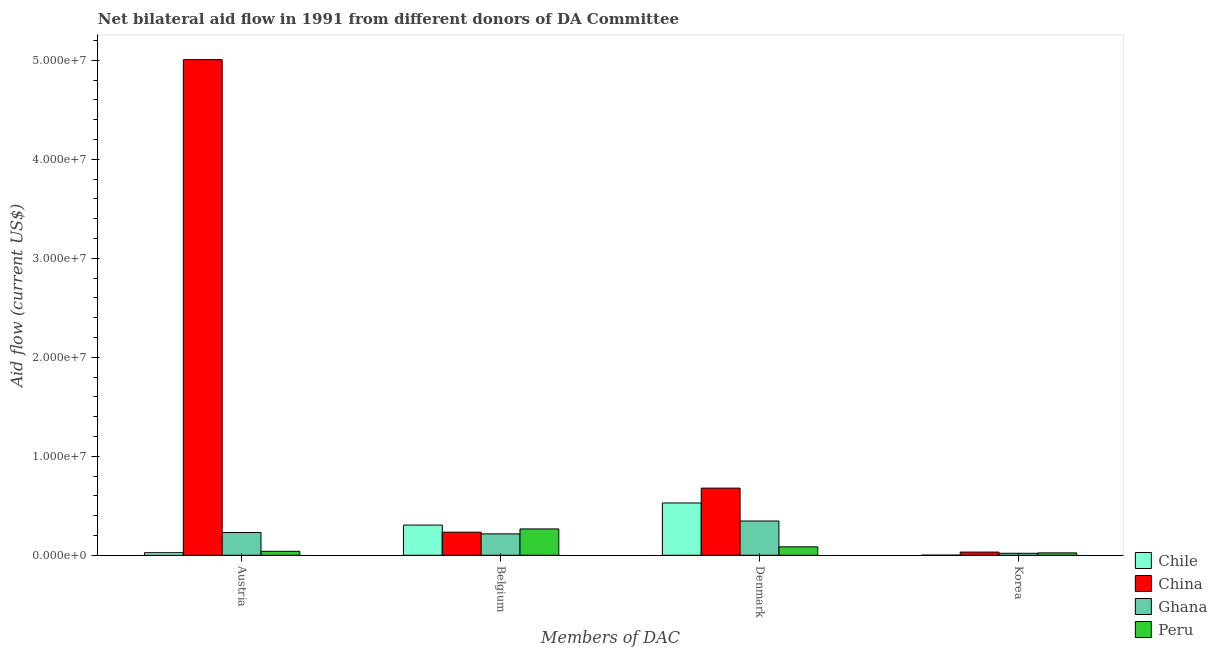How many different coloured bars are there?
Provide a short and direct response. 4. Are the number of bars on each tick of the X-axis equal?
Make the answer very short. Yes. How many bars are there on the 3rd tick from the left?
Give a very brief answer. 4. How many bars are there on the 1st tick from the right?
Your answer should be compact. 4. What is the label of the 4th group of bars from the left?
Provide a succinct answer. Korea. What is the amount of aid given by denmark in China?
Your answer should be compact. 6.78e+06. Across all countries, what is the maximum amount of aid given by korea?
Offer a terse response. 3.20e+05. Across all countries, what is the minimum amount of aid given by denmark?
Your response must be concise. 8.50e+05. In which country was the amount of aid given by belgium maximum?
Provide a short and direct response. Chile. What is the total amount of aid given by korea in the graph?
Offer a terse response. 7.70e+05. What is the difference between the amount of aid given by belgium in Chile and that in Ghana?
Ensure brevity in your answer.  8.90e+05. What is the difference between the amount of aid given by austria in Chile and the amount of aid given by korea in Peru?
Provide a succinct answer. 2.00e+04. What is the average amount of aid given by korea per country?
Offer a very short reply. 1.92e+05. What is the difference between the amount of aid given by korea and amount of aid given by belgium in Peru?
Make the answer very short. -2.42e+06. In how many countries, is the amount of aid given by korea greater than 32000000 US$?
Provide a succinct answer. 0. What is the ratio of the amount of aid given by austria in Chile to that in Ghana?
Your answer should be compact. 0.11. Is the difference between the amount of aid given by korea in Peru and Ghana greater than the difference between the amount of aid given by austria in Peru and Ghana?
Provide a short and direct response. Yes. What is the difference between the highest and the second highest amount of aid given by austria?
Keep it short and to the point. 4.78e+07. What is the difference between the highest and the lowest amount of aid given by austria?
Keep it short and to the point. 4.98e+07. In how many countries, is the amount of aid given by belgium greater than the average amount of aid given by belgium taken over all countries?
Keep it short and to the point. 2. Is it the case that in every country, the sum of the amount of aid given by austria and amount of aid given by denmark is greater than the sum of amount of aid given by belgium and amount of aid given by korea?
Give a very brief answer. No. Is it the case that in every country, the sum of the amount of aid given by austria and amount of aid given by belgium is greater than the amount of aid given by denmark?
Give a very brief answer. No. Are all the bars in the graph horizontal?
Provide a succinct answer. No. Does the graph contain grids?
Provide a short and direct response. No. Where does the legend appear in the graph?
Offer a terse response. Bottom right. How many legend labels are there?
Provide a short and direct response. 4. What is the title of the graph?
Provide a succinct answer. Net bilateral aid flow in 1991 from different donors of DA Committee. What is the label or title of the X-axis?
Your answer should be compact. Members of DAC. What is the label or title of the Y-axis?
Provide a short and direct response. Aid flow (current US$). What is the Aid flow (current US$) of Chile in Austria?
Ensure brevity in your answer.  2.60e+05. What is the Aid flow (current US$) of China in Austria?
Your answer should be very brief. 5.01e+07. What is the Aid flow (current US$) in Ghana in Austria?
Ensure brevity in your answer.  2.30e+06. What is the Aid flow (current US$) of Peru in Austria?
Your response must be concise. 4.00e+05. What is the Aid flow (current US$) in Chile in Belgium?
Make the answer very short. 3.05e+06. What is the Aid flow (current US$) of China in Belgium?
Ensure brevity in your answer.  2.33e+06. What is the Aid flow (current US$) of Ghana in Belgium?
Your answer should be very brief. 2.16e+06. What is the Aid flow (current US$) in Peru in Belgium?
Provide a succinct answer. 2.66e+06. What is the Aid flow (current US$) of Chile in Denmark?
Provide a succinct answer. 5.28e+06. What is the Aid flow (current US$) of China in Denmark?
Keep it short and to the point. 6.78e+06. What is the Aid flow (current US$) in Ghana in Denmark?
Provide a succinct answer. 3.46e+06. What is the Aid flow (current US$) of Peru in Denmark?
Provide a succinct answer. 8.50e+05. What is the Aid flow (current US$) of Chile in Korea?
Provide a short and direct response. 10000. What is the Aid flow (current US$) in Ghana in Korea?
Your response must be concise. 2.00e+05. Across all Members of DAC, what is the maximum Aid flow (current US$) of Chile?
Your answer should be very brief. 5.28e+06. Across all Members of DAC, what is the maximum Aid flow (current US$) in China?
Give a very brief answer. 5.01e+07. Across all Members of DAC, what is the maximum Aid flow (current US$) in Ghana?
Your response must be concise. 3.46e+06. Across all Members of DAC, what is the maximum Aid flow (current US$) in Peru?
Provide a succinct answer. 2.66e+06. Across all Members of DAC, what is the minimum Aid flow (current US$) of Ghana?
Keep it short and to the point. 2.00e+05. What is the total Aid flow (current US$) of Chile in the graph?
Your response must be concise. 8.60e+06. What is the total Aid flow (current US$) of China in the graph?
Offer a terse response. 5.95e+07. What is the total Aid flow (current US$) of Ghana in the graph?
Give a very brief answer. 8.12e+06. What is the total Aid flow (current US$) of Peru in the graph?
Your answer should be very brief. 4.15e+06. What is the difference between the Aid flow (current US$) in Chile in Austria and that in Belgium?
Your answer should be compact. -2.79e+06. What is the difference between the Aid flow (current US$) in China in Austria and that in Belgium?
Your response must be concise. 4.77e+07. What is the difference between the Aid flow (current US$) of Peru in Austria and that in Belgium?
Give a very brief answer. -2.26e+06. What is the difference between the Aid flow (current US$) of Chile in Austria and that in Denmark?
Offer a very short reply. -5.02e+06. What is the difference between the Aid flow (current US$) in China in Austria and that in Denmark?
Ensure brevity in your answer.  4.33e+07. What is the difference between the Aid flow (current US$) in Ghana in Austria and that in Denmark?
Give a very brief answer. -1.16e+06. What is the difference between the Aid flow (current US$) in Peru in Austria and that in Denmark?
Make the answer very short. -4.50e+05. What is the difference between the Aid flow (current US$) in China in Austria and that in Korea?
Make the answer very short. 4.97e+07. What is the difference between the Aid flow (current US$) of Ghana in Austria and that in Korea?
Give a very brief answer. 2.10e+06. What is the difference between the Aid flow (current US$) of Peru in Austria and that in Korea?
Your answer should be very brief. 1.60e+05. What is the difference between the Aid flow (current US$) in Chile in Belgium and that in Denmark?
Ensure brevity in your answer.  -2.23e+06. What is the difference between the Aid flow (current US$) in China in Belgium and that in Denmark?
Provide a short and direct response. -4.45e+06. What is the difference between the Aid flow (current US$) in Ghana in Belgium and that in Denmark?
Provide a short and direct response. -1.30e+06. What is the difference between the Aid flow (current US$) of Peru in Belgium and that in Denmark?
Your answer should be very brief. 1.81e+06. What is the difference between the Aid flow (current US$) in Chile in Belgium and that in Korea?
Your answer should be very brief. 3.04e+06. What is the difference between the Aid flow (current US$) of China in Belgium and that in Korea?
Provide a short and direct response. 2.01e+06. What is the difference between the Aid flow (current US$) in Ghana in Belgium and that in Korea?
Your response must be concise. 1.96e+06. What is the difference between the Aid flow (current US$) of Peru in Belgium and that in Korea?
Provide a succinct answer. 2.42e+06. What is the difference between the Aid flow (current US$) of Chile in Denmark and that in Korea?
Offer a terse response. 5.27e+06. What is the difference between the Aid flow (current US$) of China in Denmark and that in Korea?
Offer a terse response. 6.46e+06. What is the difference between the Aid flow (current US$) in Ghana in Denmark and that in Korea?
Offer a very short reply. 3.26e+06. What is the difference between the Aid flow (current US$) of Chile in Austria and the Aid flow (current US$) of China in Belgium?
Keep it short and to the point. -2.07e+06. What is the difference between the Aid flow (current US$) in Chile in Austria and the Aid flow (current US$) in Ghana in Belgium?
Provide a short and direct response. -1.90e+06. What is the difference between the Aid flow (current US$) in Chile in Austria and the Aid flow (current US$) in Peru in Belgium?
Your response must be concise. -2.40e+06. What is the difference between the Aid flow (current US$) of China in Austria and the Aid flow (current US$) of Ghana in Belgium?
Your response must be concise. 4.79e+07. What is the difference between the Aid flow (current US$) in China in Austria and the Aid flow (current US$) in Peru in Belgium?
Your response must be concise. 4.74e+07. What is the difference between the Aid flow (current US$) in Ghana in Austria and the Aid flow (current US$) in Peru in Belgium?
Provide a short and direct response. -3.60e+05. What is the difference between the Aid flow (current US$) in Chile in Austria and the Aid flow (current US$) in China in Denmark?
Keep it short and to the point. -6.52e+06. What is the difference between the Aid flow (current US$) of Chile in Austria and the Aid flow (current US$) of Ghana in Denmark?
Your response must be concise. -3.20e+06. What is the difference between the Aid flow (current US$) in Chile in Austria and the Aid flow (current US$) in Peru in Denmark?
Provide a succinct answer. -5.90e+05. What is the difference between the Aid flow (current US$) in China in Austria and the Aid flow (current US$) in Ghana in Denmark?
Your response must be concise. 4.66e+07. What is the difference between the Aid flow (current US$) in China in Austria and the Aid flow (current US$) in Peru in Denmark?
Offer a terse response. 4.92e+07. What is the difference between the Aid flow (current US$) in Ghana in Austria and the Aid flow (current US$) in Peru in Denmark?
Provide a short and direct response. 1.45e+06. What is the difference between the Aid flow (current US$) of Chile in Austria and the Aid flow (current US$) of Peru in Korea?
Your response must be concise. 2.00e+04. What is the difference between the Aid flow (current US$) of China in Austria and the Aid flow (current US$) of Ghana in Korea?
Provide a short and direct response. 4.99e+07. What is the difference between the Aid flow (current US$) of China in Austria and the Aid flow (current US$) of Peru in Korea?
Offer a terse response. 4.98e+07. What is the difference between the Aid flow (current US$) in Ghana in Austria and the Aid flow (current US$) in Peru in Korea?
Give a very brief answer. 2.06e+06. What is the difference between the Aid flow (current US$) in Chile in Belgium and the Aid flow (current US$) in China in Denmark?
Offer a very short reply. -3.73e+06. What is the difference between the Aid flow (current US$) in Chile in Belgium and the Aid flow (current US$) in Ghana in Denmark?
Your response must be concise. -4.10e+05. What is the difference between the Aid flow (current US$) in Chile in Belgium and the Aid flow (current US$) in Peru in Denmark?
Provide a short and direct response. 2.20e+06. What is the difference between the Aid flow (current US$) in China in Belgium and the Aid flow (current US$) in Ghana in Denmark?
Your answer should be compact. -1.13e+06. What is the difference between the Aid flow (current US$) in China in Belgium and the Aid flow (current US$) in Peru in Denmark?
Provide a succinct answer. 1.48e+06. What is the difference between the Aid flow (current US$) in Ghana in Belgium and the Aid flow (current US$) in Peru in Denmark?
Your answer should be very brief. 1.31e+06. What is the difference between the Aid flow (current US$) of Chile in Belgium and the Aid flow (current US$) of China in Korea?
Provide a short and direct response. 2.73e+06. What is the difference between the Aid flow (current US$) in Chile in Belgium and the Aid flow (current US$) in Ghana in Korea?
Give a very brief answer. 2.85e+06. What is the difference between the Aid flow (current US$) of Chile in Belgium and the Aid flow (current US$) of Peru in Korea?
Your response must be concise. 2.81e+06. What is the difference between the Aid flow (current US$) of China in Belgium and the Aid flow (current US$) of Ghana in Korea?
Your answer should be compact. 2.13e+06. What is the difference between the Aid flow (current US$) in China in Belgium and the Aid flow (current US$) in Peru in Korea?
Keep it short and to the point. 2.09e+06. What is the difference between the Aid flow (current US$) of Ghana in Belgium and the Aid flow (current US$) of Peru in Korea?
Offer a terse response. 1.92e+06. What is the difference between the Aid flow (current US$) in Chile in Denmark and the Aid flow (current US$) in China in Korea?
Give a very brief answer. 4.96e+06. What is the difference between the Aid flow (current US$) of Chile in Denmark and the Aid flow (current US$) of Ghana in Korea?
Make the answer very short. 5.08e+06. What is the difference between the Aid flow (current US$) in Chile in Denmark and the Aid flow (current US$) in Peru in Korea?
Give a very brief answer. 5.04e+06. What is the difference between the Aid flow (current US$) of China in Denmark and the Aid flow (current US$) of Ghana in Korea?
Provide a short and direct response. 6.58e+06. What is the difference between the Aid flow (current US$) in China in Denmark and the Aid flow (current US$) in Peru in Korea?
Your response must be concise. 6.54e+06. What is the difference between the Aid flow (current US$) in Ghana in Denmark and the Aid flow (current US$) in Peru in Korea?
Provide a succinct answer. 3.22e+06. What is the average Aid flow (current US$) in Chile per Members of DAC?
Your answer should be compact. 2.15e+06. What is the average Aid flow (current US$) of China per Members of DAC?
Offer a very short reply. 1.49e+07. What is the average Aid flow (current US$) of Ghana per Members of DAC?
Keep it short and to the point. 2.03e+06. What is the average Aid flow (current US$) of Peru per Members of DAC?
Give a very brief answer. 1.04e+06. What is the difference between the Aid flow (current US$) in Chile and Aid flow (current US$) in China in Austria?
Offer a very short reply. -4.98e+07. What is the difference between the Aid flow (current US$) of Chile and Aid flow (current US$) of Ghana in Austria?
Provide a succinct answer. -2.04e+06. What is the difference between the Aid flow (current US$) of China and Aid flow (current US$) of Ghana in Austria?
Make the answer very short. 4.78e+07. What is the difference between the Aid flow (current US$) in China and Aid flow (current US$) in Peru in Austria?
Offer a terse response. 4.97e+07. What is the difference between the Aid flow (current US$) in Ghana and Aid flow (current US$) in Peru in Austria?
Provide a succinct answer. 1.90e+06. What is the difference between the Aid flow (current US$) of Chile and Aid flow (current US$) of China in Belgium?
Your answer should be compact. 7.20e+05. What is the difference between the Aid flow (current US$) in Chile and Aid flow (current US$) in Ghana in Belgium?
Provide a succinct answer. 8.90e+05. What is the difference between the Aid flow (current US$) in Chile and Aid flow (current US$) in Peru in Belgium?
Your response must be concise. 3.90e+05. What is the difference between the Aid flow (current US$) in China and Aid flow (current US$) in Ghana in Belgium?
Give a very brief answer. 1.70e+05. What is the difference between the Aid flow (current US$) of China and Aid flow (current US$) of Peru in Belgium?
Your answer should be very brief. -3.30e+05. What is the difference between the Aid flow (current US$) in Ghana and Aid flow (current US$) in Peru in Belgium?
Your response must be concise. -5.00e+05. What is the difference between the Aid flow (current US$) of Chile and Aid flow (current US$) of China in Denmark?
Your answer should be very brief. -1.50e+06. What is the difference between the Aid flow (current US$) of Chile and Aid flow (current US$) of Ghana in Denmark?
Your response must be concise. 1.82e+06. What is the difference between the Aid flow (current US$) in Chile and Aid flow (current US$) in Peru in Denmark?
Give a very brief answer. 4.43e+06. What is the difference between the Aid flow (current US$) of China and Aid flow (current US$) of Ghana in Denmark?
Give a very brief answer. 3.32e+06. What is the difference between the Aid flow (current US$) in China and Aid flow (current US$) in Peru in Denmark?
Provide a succinct answer. 5.93e+06. What is the difference between the Aid flow (current US$) of Ghana and Aid flow (current US$) of Peru in Denmark?
Provide a short and direct response. 2.61e+06. What is the difference between the Aid flow (current US$) of Chile and Aid flow (current US$) of China in Korea?
Provide a succinct answer. -3.10e+05. What is the difference between the Aid flow (current US$) of Chile and Aid flow (current US$) of Ghana in Korea?
Your response must be concise. -1.90e+05. What is the difference between the Aid flow (current US$) of China and Aid flow (current US$) of Ghana in Korea?
Make the answer very short. 1.20e+05. What is the difference between the Aid flow (current US$) in Ghana and Aid flow (current US$) in Peru in Korea?
Keep it short and to the point. -4.00e+04. What is the ratio of the Aid flow (current US$) in Chile in Austria to that in Belgium?
Keep it short and to the point. 0.09. What is the ratio of the Aid flow (current US$) in China in Austria to that in Belgium?
Provide a short and direct response. 21.48. What is the ratio of the Aid flow (current US$) in Ghana in Austria to that in Belgium?
Offer a very short reply. 1.06. What is the ratio of the Aid flow (current US$) of Peru in Austria to that in Belgium?
Your answer should be compact. 0.15. What is the ratio of the Aid flow (current US$) in Chile in Austria to that in Denmark?
Offer a terse response. 0.05. What is the ratio of the Aid flow (current US$) in China in Austria to that in Denmark?
Ensure brevity in your answer.  7.38. What is the ratio of the Aid flow (current US$) in Ghana in Austria to that in Denmark?
Ensure brevity in your answer.  0.66. What is the ratio of the Aid flow (current US$) of Peru in Austria to that in Denmark?
Make the answer very short. 0.47. What is the ratio of the Aid flow (current US$) in Chile in Austria to that in Korea?
Provide a succinct answer. 26. What is the ratio of the Aid flow (current US$) of China in Austria to that in Korea?
Your response must be concise. 156.44. What is the ratio of the Aid flow (current US$) of Peru in Austria to that in Korea?
Make the answer very short. 1.67. What is the ratio of the Aid flow (current US$) of Chile in Belgium to that in Denmark?
Your answer should be compact. 0.58. What is the ratio of the Aid flow (current US$) of China in Belgium to that in Denmark?
Ensure brevity in your answer.  0.34. What is the ratio of the Aid flow (current US$) of Ghana in Belgium to that in Denmark?
Provide a short and direct response. 0.62. What is the ratio of the Aid flow (current US$) in Peru in Belgium to that in Denmark?
Your response must be concise. 3.13. What is the ratio of the Aid flow (current US$) in Chile in Belgium to that in Korea?
Make the answer very short. 305. What is the ratio of the Aid flow (current US$) in China in Belgium to that in Korea?
Keep it short and to the point. 7.28. What is the ratio of the Aid flow (current US$) in Peru in Belgium to that in Korea?
Keep it short and to the point. 11.08. What is the ratio of the Aid flow (current US$) in Chile in Denmark to that in Korea?
Keep it short and to the point. 528. What is the ratio of the Aid flow (current US$) in China in Denmark to that in Korea?
Offer a very short reply. 21.19. What is the ratio of the Aid flow (current US$) of Ghana in Denmark to that in Korea?
Your response must be concise. 17.3. What is the ratio of the Aid flow (current US$) of Peru in Denmark to that in Korea?
Give a very brief answer. 3.54. What is the difference between the highest and the second highest Aid flow (current US$) of Chile?
Offer a terse response. 2.23e+06. What is the difference between the highest and the second highest Aid flow (current US$) of China?
Provide a succinct answer. 4.33e+07. What is the difference between the highest and the second highest Aid flow (current US$) of Ghana?
Provide a short and direct response. 1.16e+06. What is the difference between the highest and the second highest Aid flow (current US$) of Peru?
Offer a terse response. 1.81e+06. What is the difference between the highest and the lowest Aid flow (current US$) in Chile?
Make the answer very short. 5.27e+06. What is the difference between the highest and the lowest Aid flow (current US$) of China?
Make the answer very short. 4.97e+07. What is the difference between the highest and the lowest Aid flow (current US$) of Ghana?
Make the answer very short. 3.26e+06. What is the difference between the highest and the lowest Aid flow (current US$) in Peru?
Offer a terse response. 2.42e+06. 